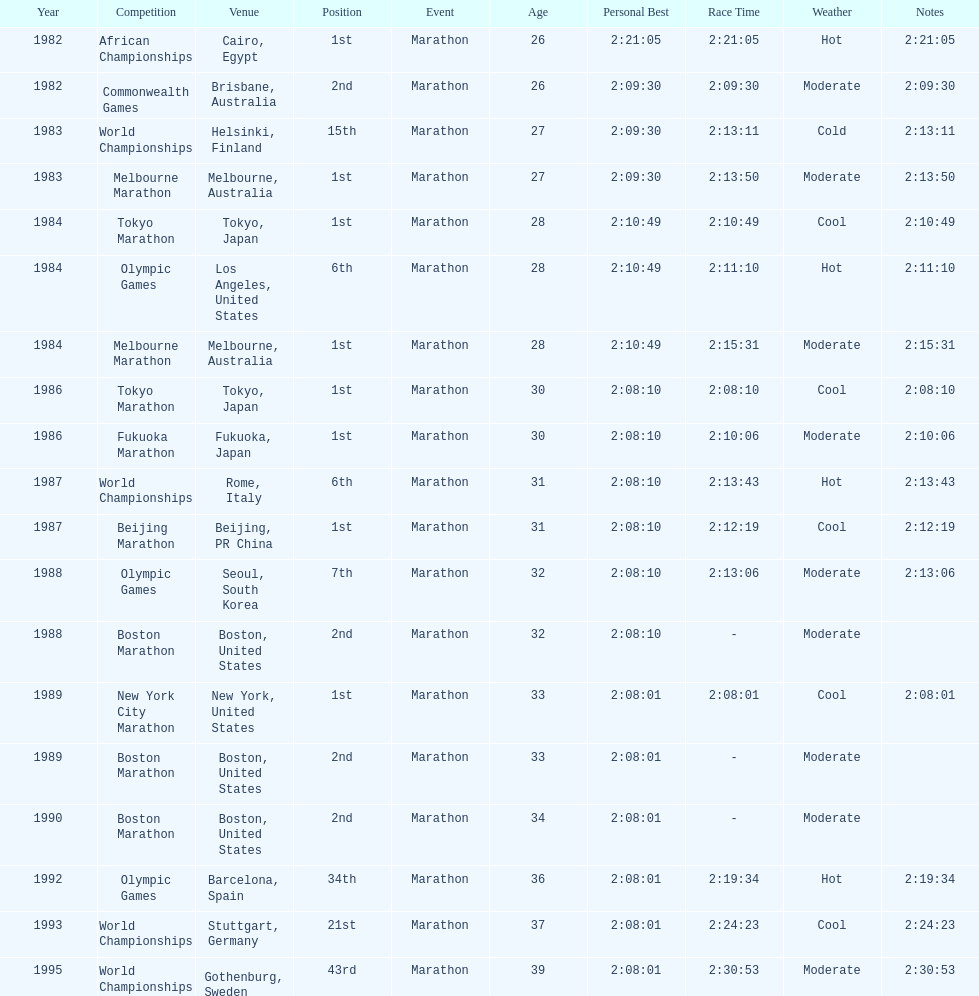Which was the only competition to occur in china? Beijing Marathon. 